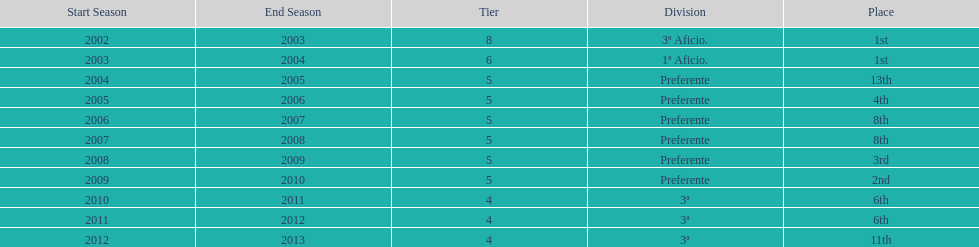What place did the team place in 2010/11? 6th. In what other year did they place 6th? 2011/12. 